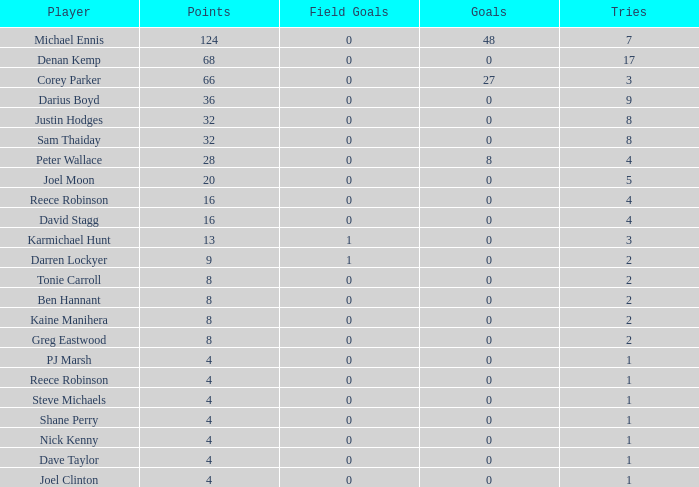How many goals did the player with less than 4 points have? 0.0. 